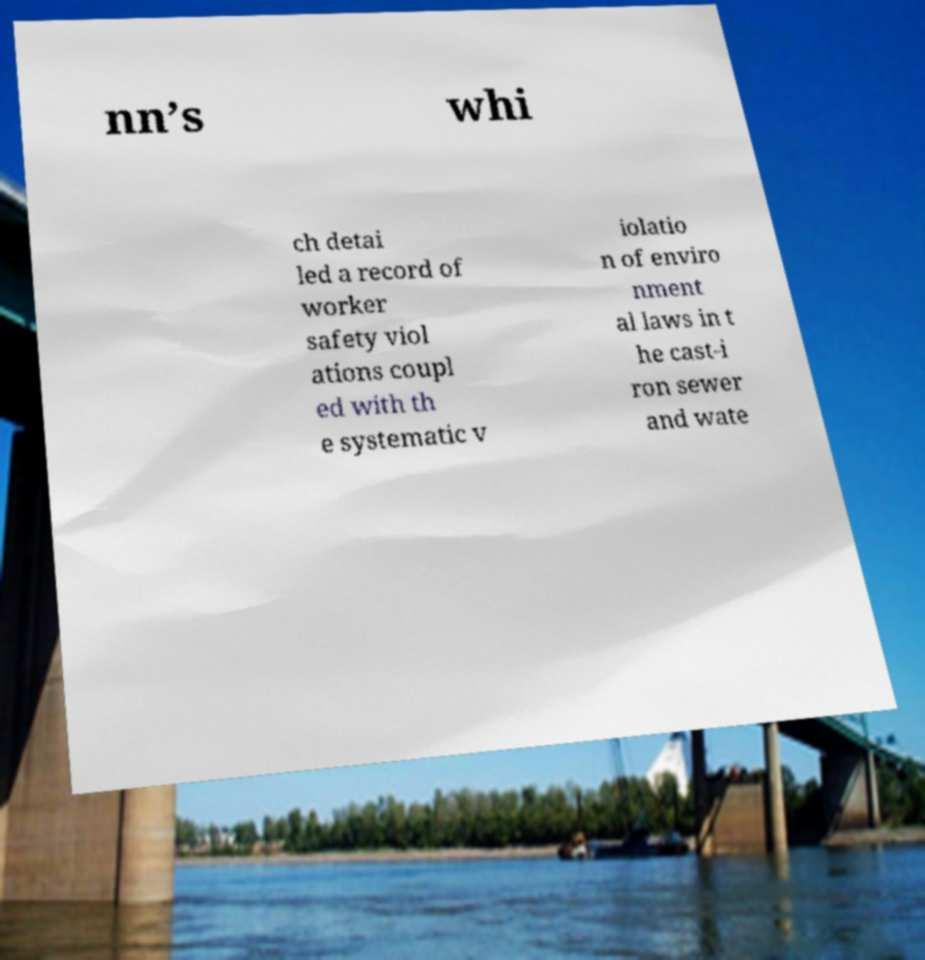I need the written content from this picture converted into text. Can you do that? nn’s whi ch detai led a record of worker safety viol ations coupl ed with th e systematic v iolatio n of enviro nment al laws in t he cast-i ron sewer and wate 